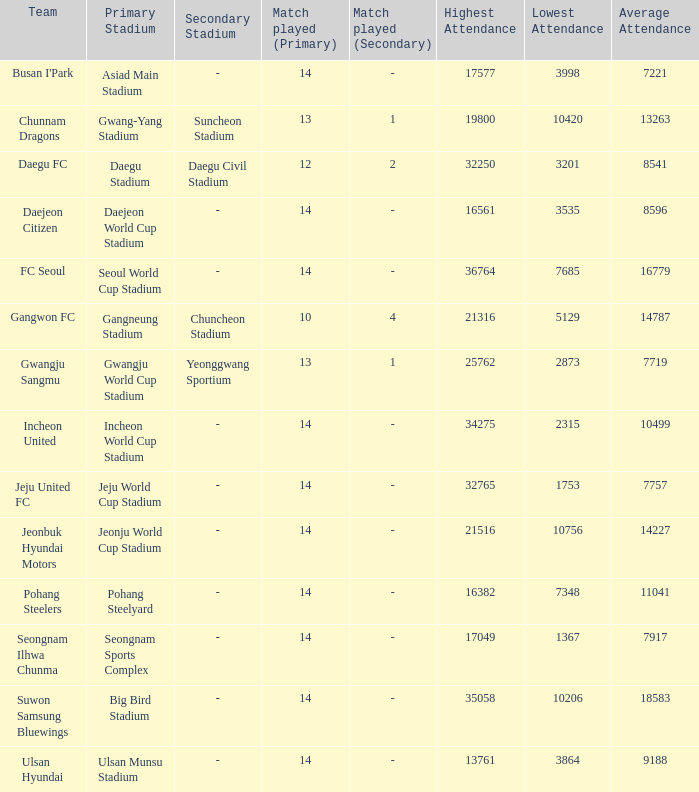What is the highest when pohang steelers is the team? 16382.0. 